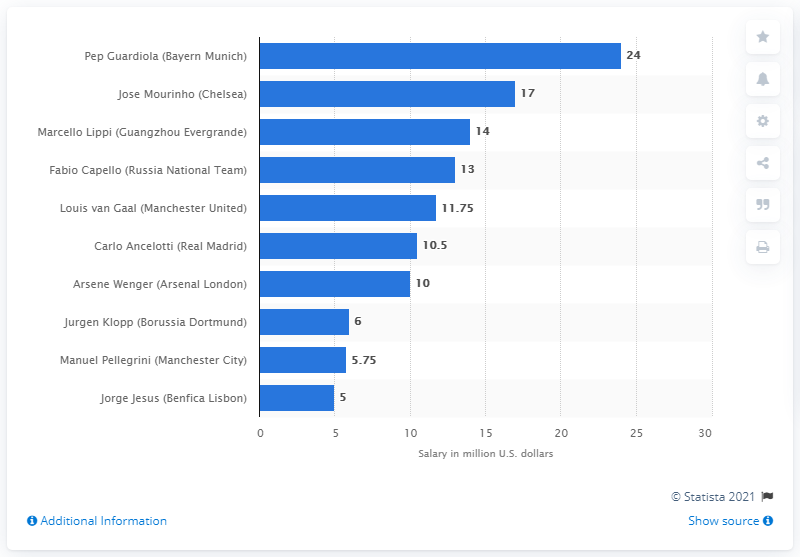List a handful of essential elements in this visual. In the 2014/15 season, Pep Guardiola earned a significant amount of money. 